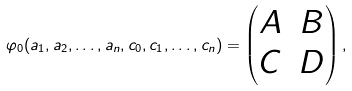<formula> <loc_0><loc_0><loc_500><loc_500>\varphi _ { 0 } ( a _ { 1 } , a _ { 2 } , \dots , a _ { n } , c _ { 0 } , c _ { 1 } , \dots , c _ { n } ) = \begin{pmatrix} A & B \\ C & D \end{pmatrix} ,</formula> 